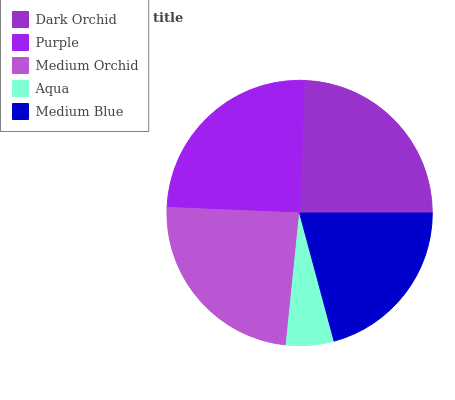Is Aqua the minimum?
Answer yes or no. Yes. Is Purple the maximum?
Answer yes or no. Yes. Is Medium Orchid the minimum?
Answer yes or no. No. Is Medium Orchid the maximum?
Answer yes or no. No. Is Purple greater than Medium Orchid?
Answer yes or no. Yes. Is Medium Orchid less than Purple?
Answer yes or no. Yes. Is Medium Orchid greater than Purple?
Answer yes or no. No. Is Purple less than Medium Orchid?
Answer yes or no. No. Is Medium Orchid the high median?
Answer yes or no. Yes. Is Medium Orchid the low median?
Answer yes or no. Yes. Is Aqua the high median?
Answer yes or no. No. Is Dark Orchid the low median?
Answer yes or no. No. 